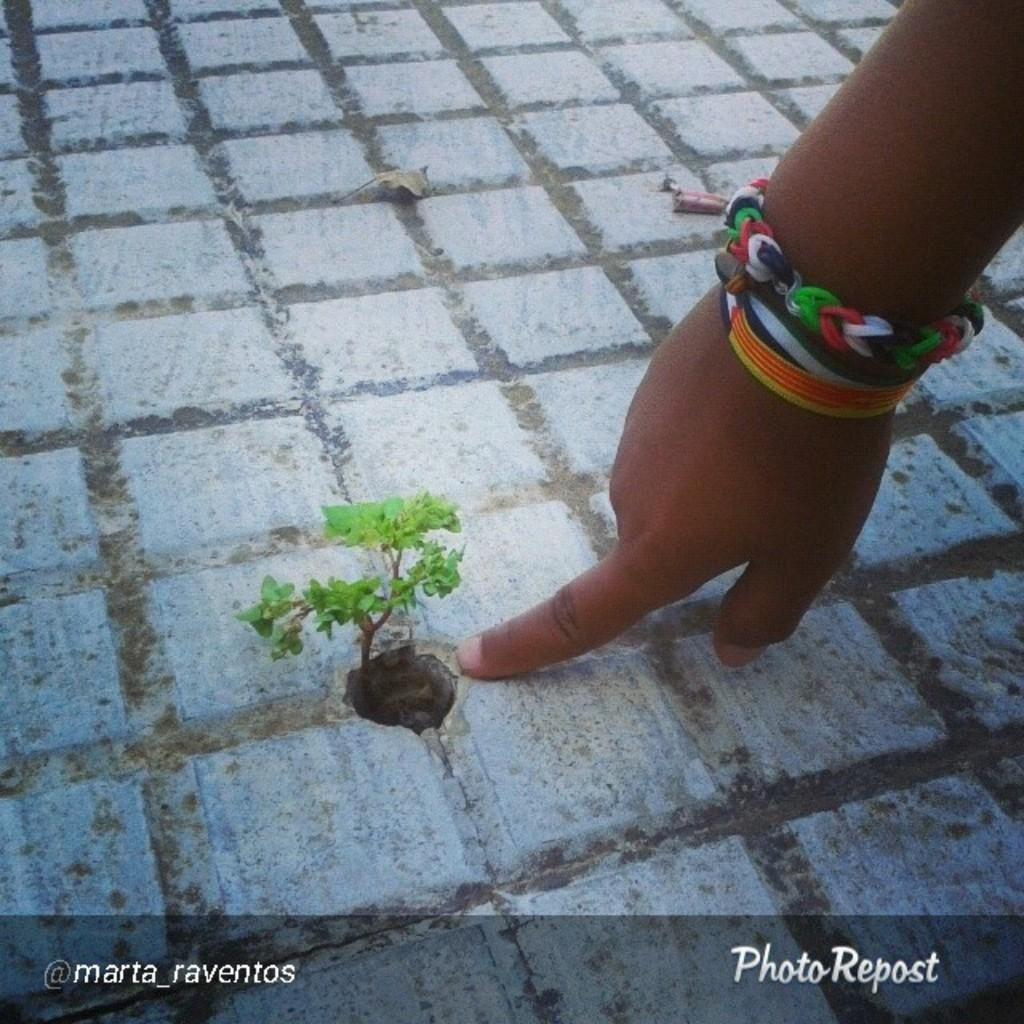What type of object is located in the hole in the image? There is a small plant in a hole in the image. What part of a person can be seen in the image? A person's hand is on the ground in the image. What can be read or seen at the bottom of the image? There is some text visible at the bottom of the image. What type of bell can be heard ringing in the image? There is no bell present in the image, and therefore no sound can be heard. What emotion is the person expressing in the image? The emotion of the person cannot be determined from the image, as only their hand is visible. 